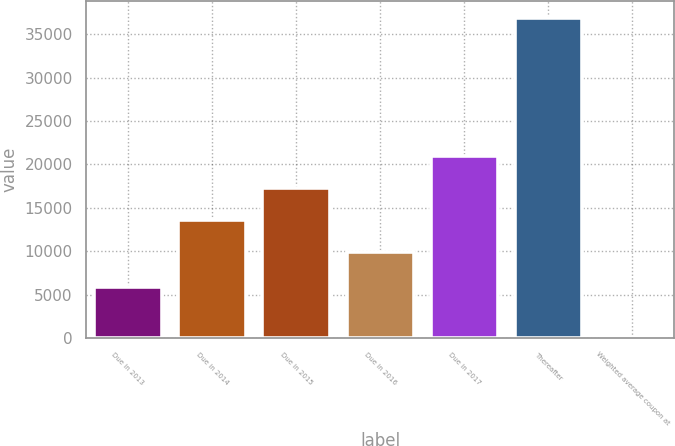Convert chart to OTSL. <chart><loc_0><loc_0><loc_500><loc_500><bar_chart><fcel>Due in 2013<fcel>Due in 2014<fcel>Due in 2015<fcel>Due in 2016<fcel>Due in 2017<fcel>Thereafter<fcel>Weighted average coupon at<nl><fcel>5867<fcel>13593.1<fcel>17284.1<fcel>9902<fcel>20975.2<fcel>36916<fcel>5.3<nl></chart> 